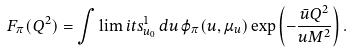<formula> <loc_0><loc_0><loc_500><loc_500>F _ { \pi } ( Q ^ { 2 } ) = \int \lim i t s _ { u _ { 0 } } ^ { 1 } \, d u \, \varphi _ { \pi } ( u , \mu _ { u } ) \exp \left ( - \frac { \bar { u } Q ^ { 2 } } { u M ^ { 2 } } \right ) .</formula> 